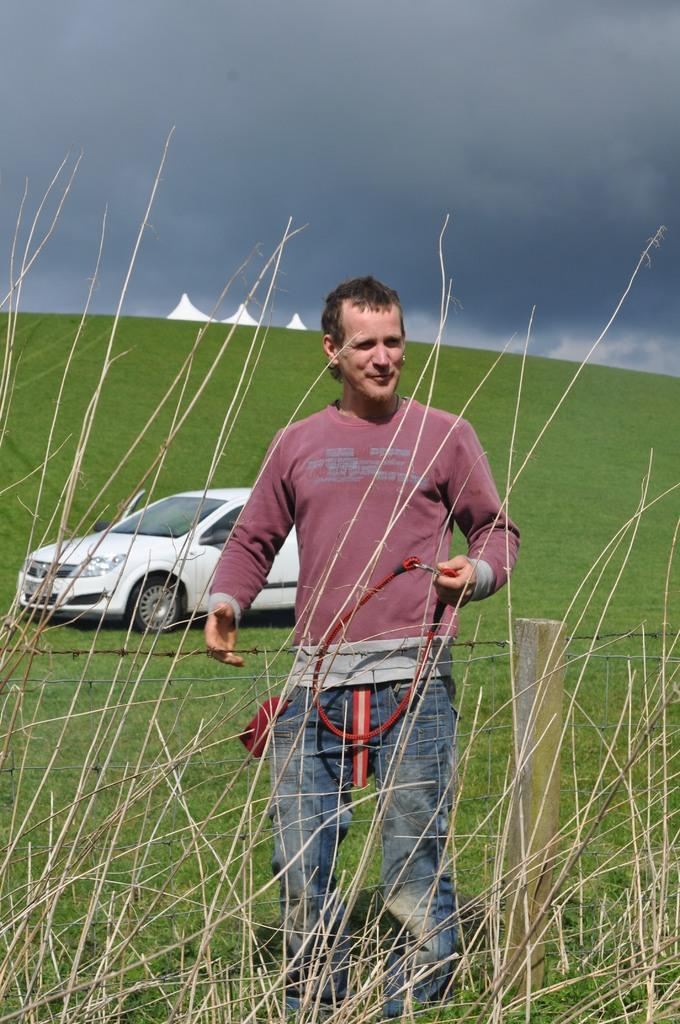What is the man in the image doing? The man is standing in the image and holding a string in his hand. What else can be seen in the image besides the man? There is a car, grass on the ground, a metal wire fence, and a blue sky visible in the image. What might the man be using the string for? It is unclear from the image what the man is using the string for. What type of terrain is visible in the image? The grass on the ground suggests that the terrain is grassy. What type of glue is being used to attach the seat to the car in the image? There is no seat or glue present in the image; it only shows a man holding a string, a car, grass, a metal wire fence, and a blue sky. 